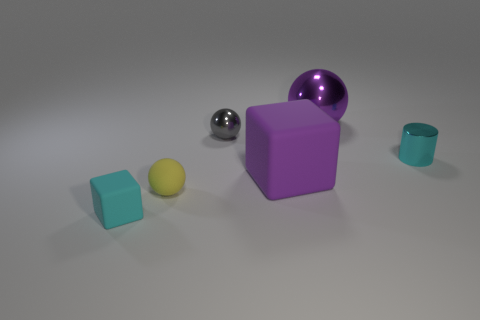Add 2 cyan shiny blocks. How many objects exist? 8 Subtract all cubes. How many objects are left? 4 Add 1 purple things. How many purple things exist? 3 Subtract 0 brown cylinders. How many objects are left? 6 Subtract all matte things. Subtract all purple spheres. How many objects are left? 2 Add 2 purple metal balls. How many purple metal balls are left? 3 